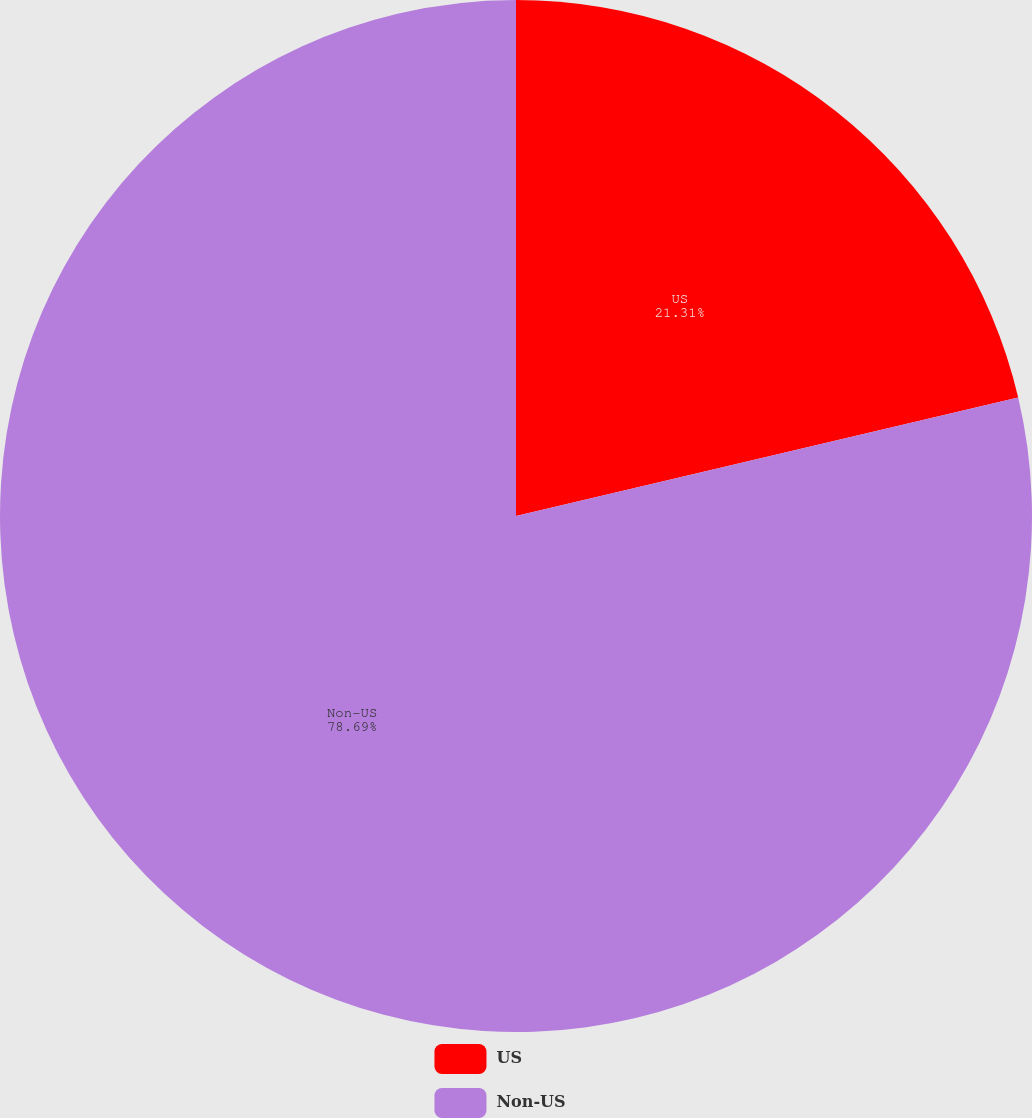Convert chart to OTSL. <chart><loc_0><loc_0><loc_500><loc_500><pie_chart><fcel>US<fcel>Non-US<nl><fcel>21.31%<fcel>78.69%<nl></chart> 